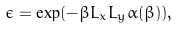Convert formula to latex. <formula><loc_0><loc_0><loc_500><loc_500>\epsilon = \exp ( - \beta L _ { x } L _ { y } \alpha ( \beta ) ) ,</formula> 